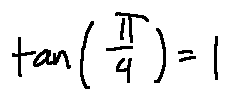<formula> <loc_0><loc_0><loc_500><loc_500>\tan ( \frac { \pi } { 4 } ) = 1</formula> 